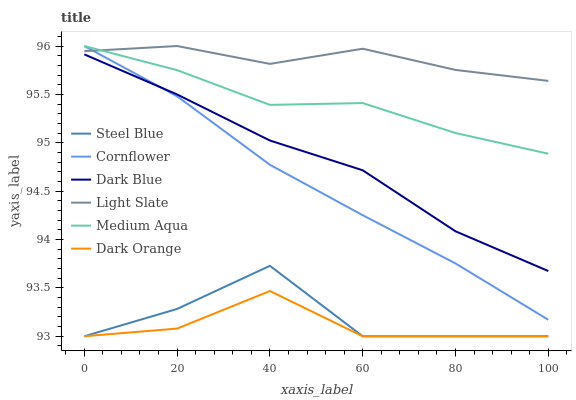Does Light Slate have the minimum area under the curve?
Answer yes or no. No. Does Dark Orange have the maximum area under the curve?
Answer yes or no. No. Is Dark Orange the smoothest?
Answer yes or no. No. Is Dark Orange the roughest?
Answer yes or no. No. Does Light Slate have the lowest value?
Answer yes or no. No. Does Dark Orange have the highest value?
Answer yes or no. No. Is Dark Blue less than Light Slate?
Answer yes or no. Yes. Is Light Slate greater than Dark Blue?
Answer yes or no. Yes. Does Dark Blue intersect Light Slate?
Answer yes or no. No. 